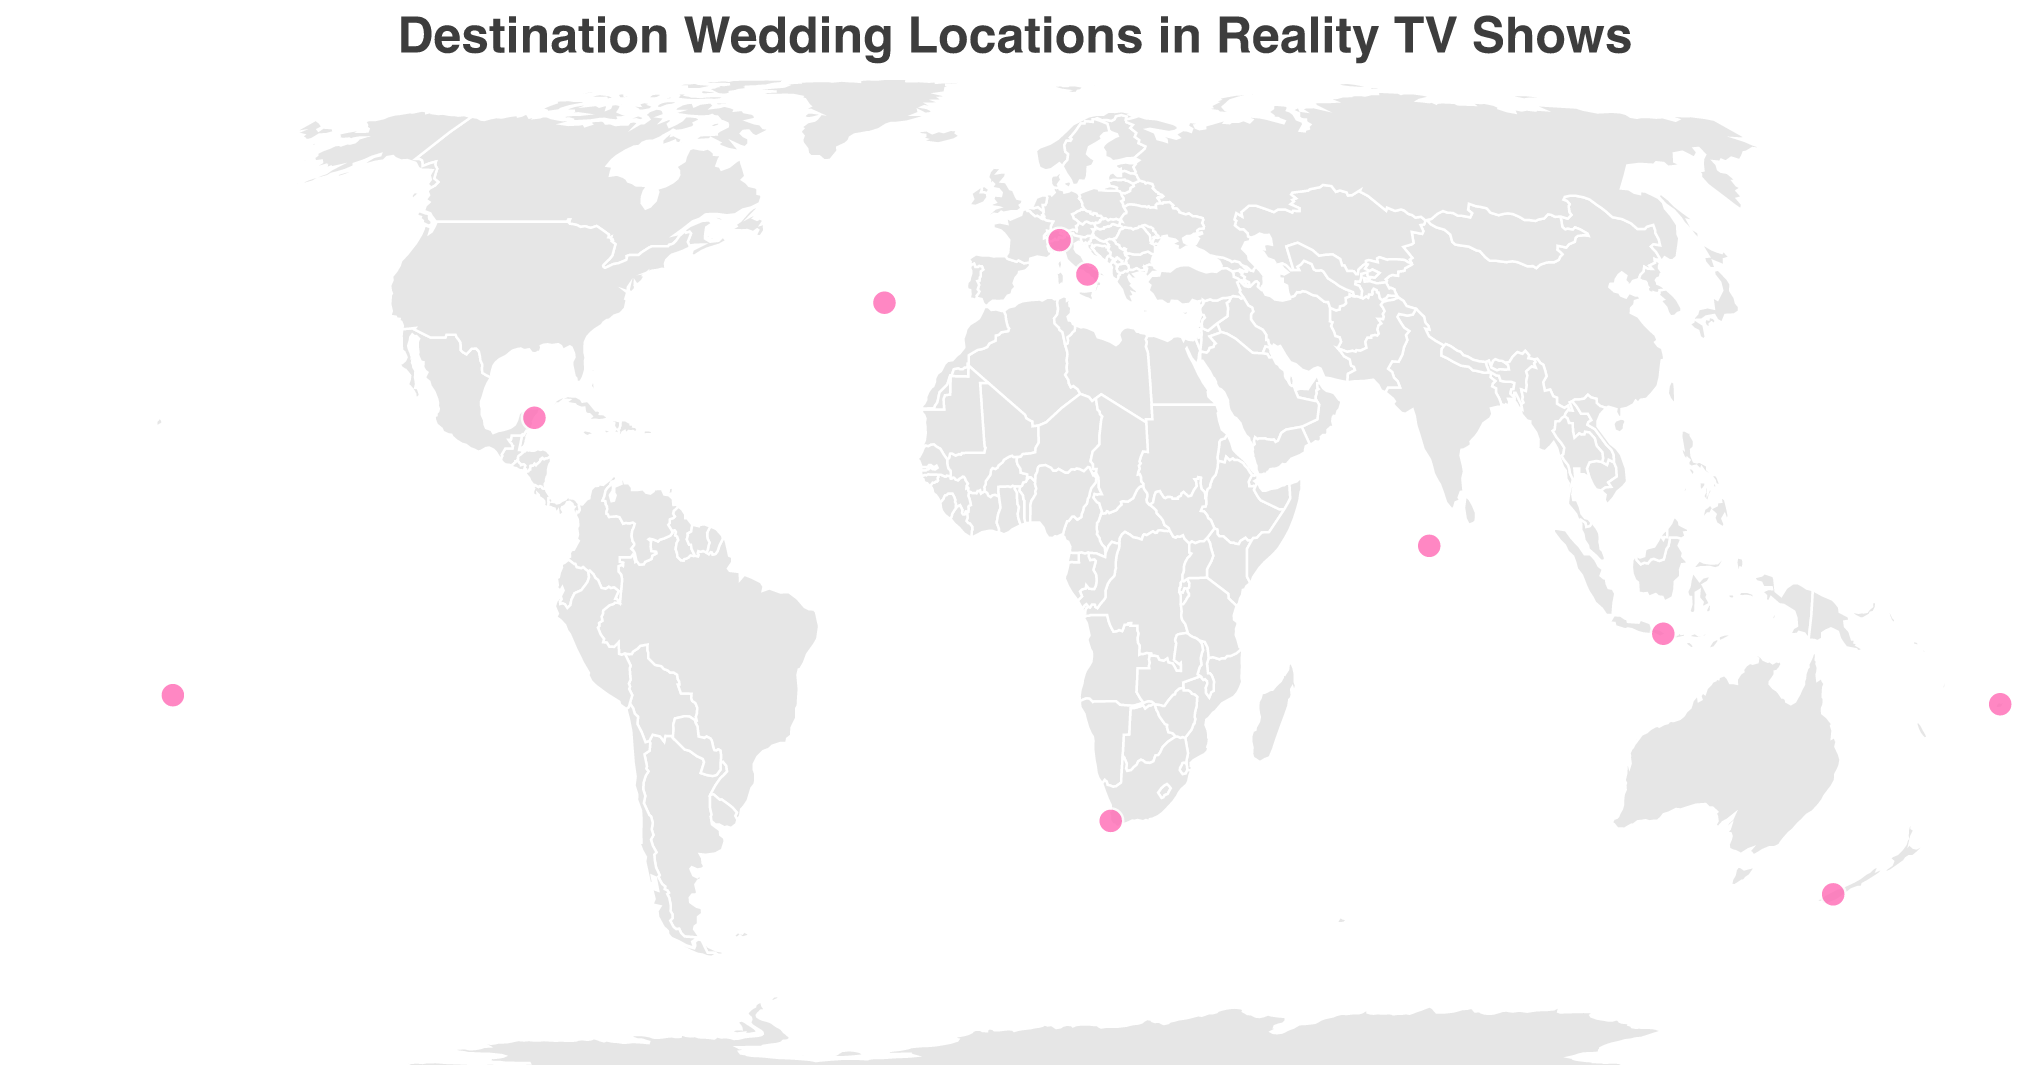Which country has the most destinations featured in the plot? By examining the geographic plot, we can see that Italy has two locations marked: Positano and Lake Como. All other countries have only one location marked.
Answer: Italy Which reality TV show is represented by a destination in the Maldives? By hovering over the point near the Maldives in the plot, we can see that the show linked to this destination is "90 Day Fiancé."
Answer: 90 Day Fiancé Which couple got married in Bali, Indonesia? Hovering over the circle marker in Indonesia shows the tooltip information indicating the couple "Jules and Cam" featured in the show "Married at First Sight."
Answer: Jules and Cam What is the latitude and longitude of the wedding location in Cape Town, South Africa? By examining the plot and hovering over Cape Town, we get the geographic coordinates as latitude -33.9249 and longitude 18.4241.
Answer: Latitude: -33.9249, Longitude: 18.4241 How many destination wedding locations are there in the Pacific region (e.g., Fiji, Bora Bora)? The Pacific locations with destination weddings in the plot are Bora Bora, Fiji, and Maldives. Counting these markers, we find there are 3 locations.
Answer: 3 Which destination wedding is located closest to the equator? By checking the latitude values of all the locations, the one closest to zero (the equator) is the Maldives with a latitude of 3.2028.
Answer: Maldives Which locations are featured in shows titled "The Bachelor," and where are they located? By examining the geographic plot and hovering over the points, "The Bachelor" is linked to Santorini, Greece and Queenstown, New Zealand.
Answer: Santorini, Greece and Queenstown, New Zealand Which location is furthest south on the map? By checking the latitude values, Queenstown, New Zealand is furthest south, with a latitude of -45.0312.
Answer: Queenstown, New Zealand How many reality TV shows have their destination weddings featured in Europe? In Europe, the featured destinations are Santorini (Greece) and Positano, Lake Como (Italy), making for a total of 2 distinct shows: The Bachelor and Vanderpump Rules, The Hills.
Answer: 3 What's the average longitude of all the wedding locations in Italy? The longitudes of Italian locations (Positano and Lake Como) are 14.4850 and 9.2560. The average is calculated as (14.4850 + 9.2560) / 2 = 11.8705.
Answer: 11.8705 